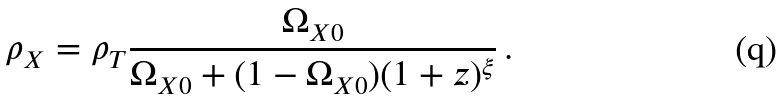Convert formula to latex. <formula><loc_0><loc_0><loc_500><loc_500>\rho _ { X } = \rho _ { T } \frac { \Omega _ { X 0 } } { \Omega _ { X 0 } + ( 1 - \Omega _ { X 0 } ) ( 1 + z ) ^ { \xi } } \, .</formula> 